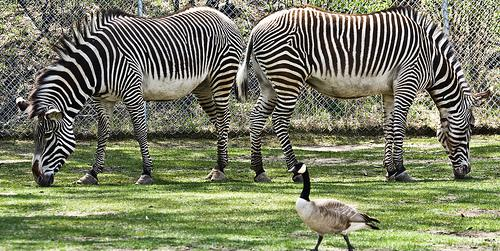Question: what is this place?
Choices:
A. A zoo.
B. A farm.
C. An animal park.
D. A city.
Answer with the letter. Answer: C Question: how many legs do the zebras have?
Choices:
A. 3.
B. 4.
C. 2.
D. 5.
Answer with the letter. Answer: B Question: why are the animals looking down?
Choices:
A. They are eating.
B. They are searching for something.
C. They are playing.
D. They are hiding.
Answer with the letter. Answer: A Question: what else is seen in the photo?
Choices:
A. A cat.
B. A dog.
C. A horse.
D. A bird.
Answer with the letter. Answer: D Question: what are the animals eating?
Choices:
A. Feed.
B. Oats.
C. Grass.
D. Steak.
Answer with the letter. Answer: C 